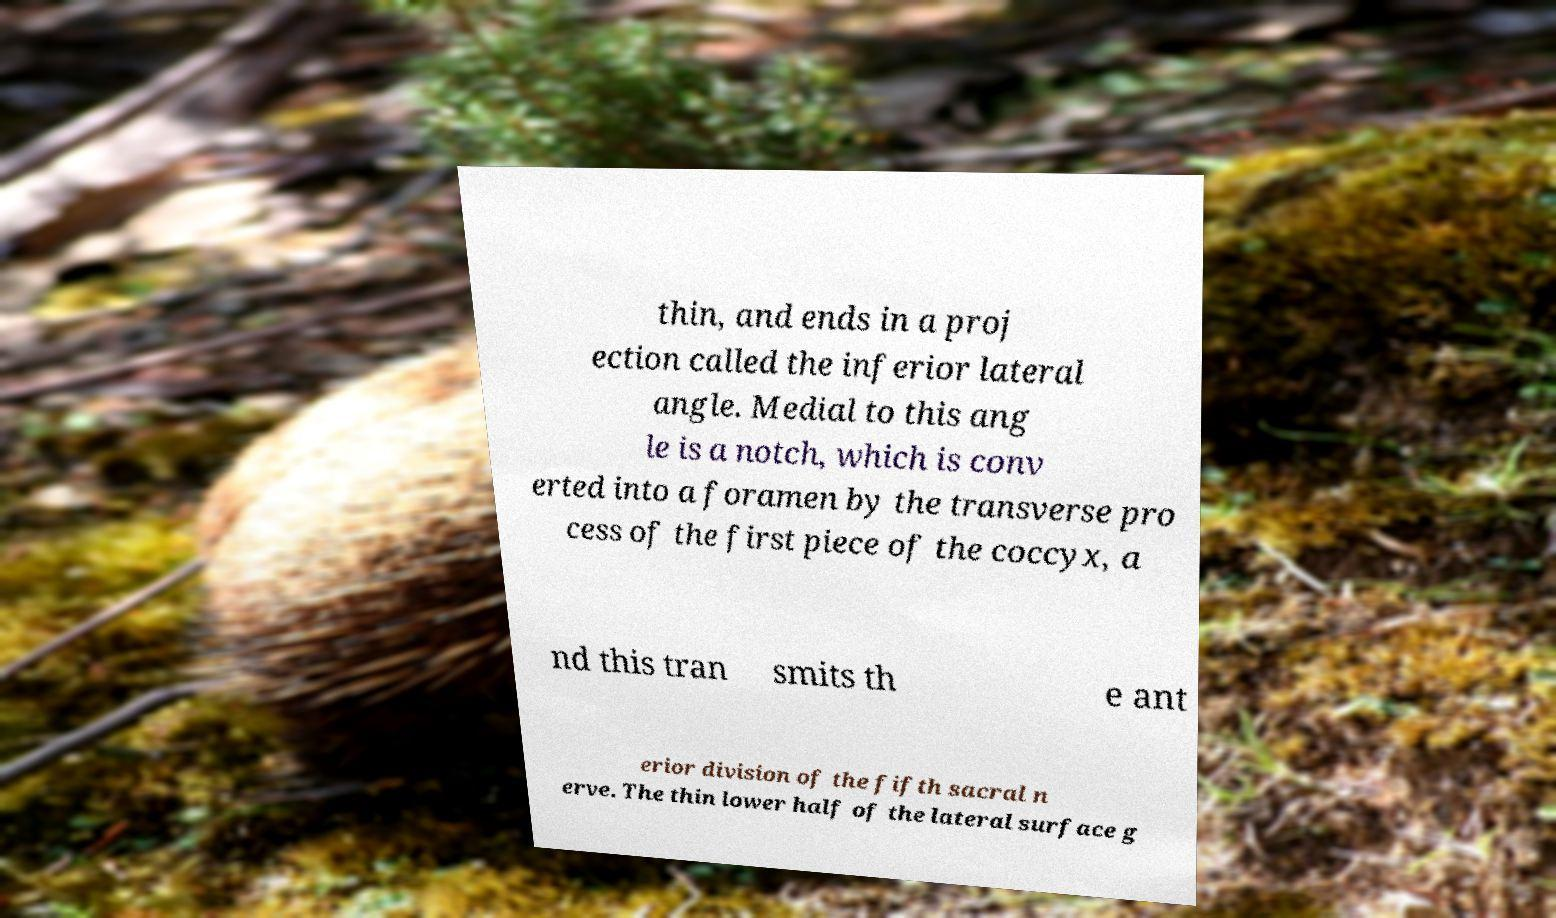Please read and relay the text visible in this image. What does it say? thin, and ends in a proj ection called the inferior lateral angle. Medial to this ang le is a notch, which is conv erted into a foramen by the transverse pro cess of the first piece of the coccyx, a nd this tran smits th e ant erior division of the fifth sacral n erve. The thin lower half of the lateral surface g 